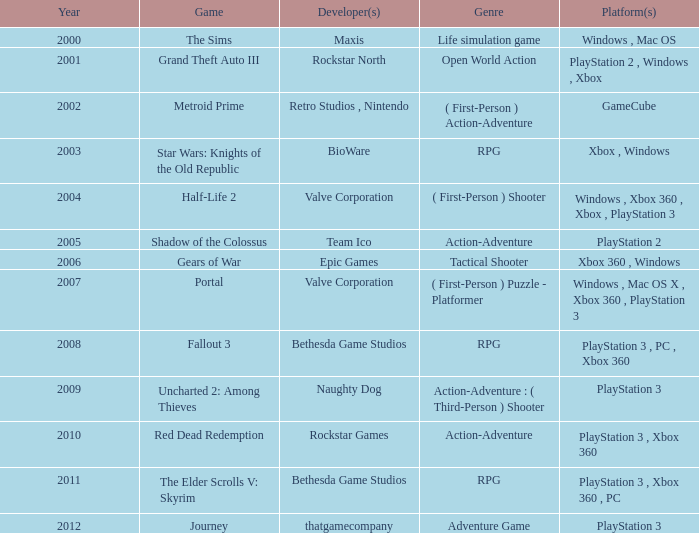What game was available in 2005? Shadow of the Colossus. 